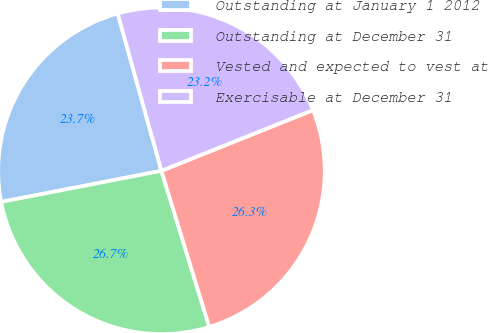Convert chart. <chart><loc_0><loc_0><loc_500><loc_500><pie_chart><fcel>Outstanding at January 1 2012<fcel>Outstanding at December 31<fcel>Vested and expected to vest at<fcel>Exercisable at December 31<nl><fcel>23.74%<fcel>26.68%<fcel>26.34%<fcel>23.25%<nl></chart> 